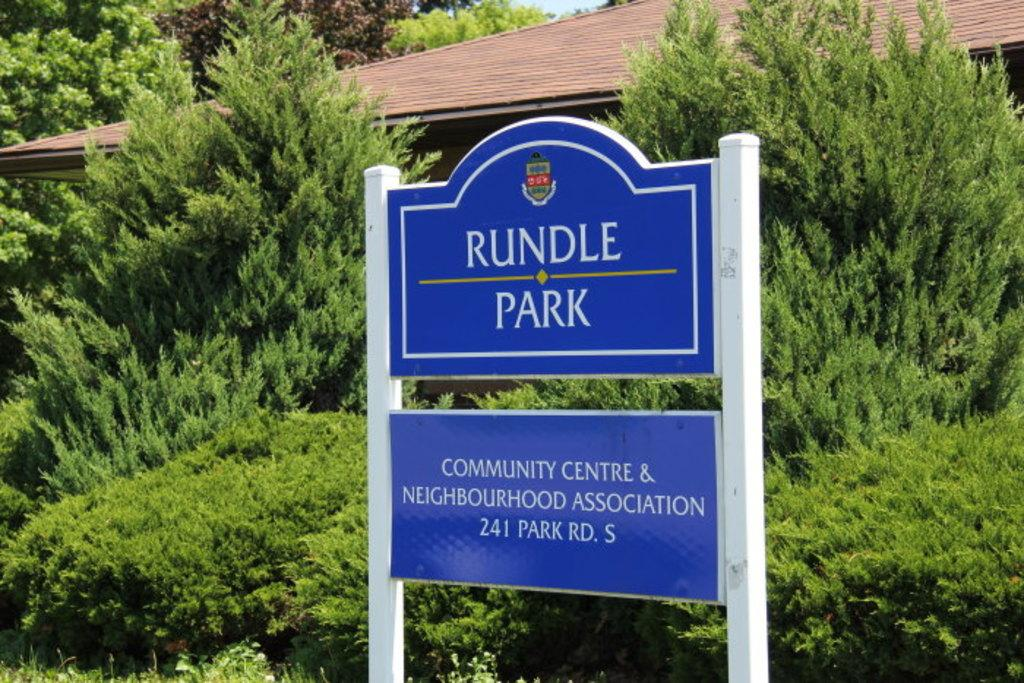What is located in the foreground of the picture? There is a board in the foreground of the picture. What can be seen in the center of the picture? There are plants and trees in the center of the picture, as well as a house. What is visible in the background of the picture? There are trees in the background of the picture. How many daughters can be seen playing with smoke in the image? There are no daughters or smoke present in the image. What type of cent is visible in the center of the image? There is no cent present in the image; it features a house, plants, trees, and a board. 